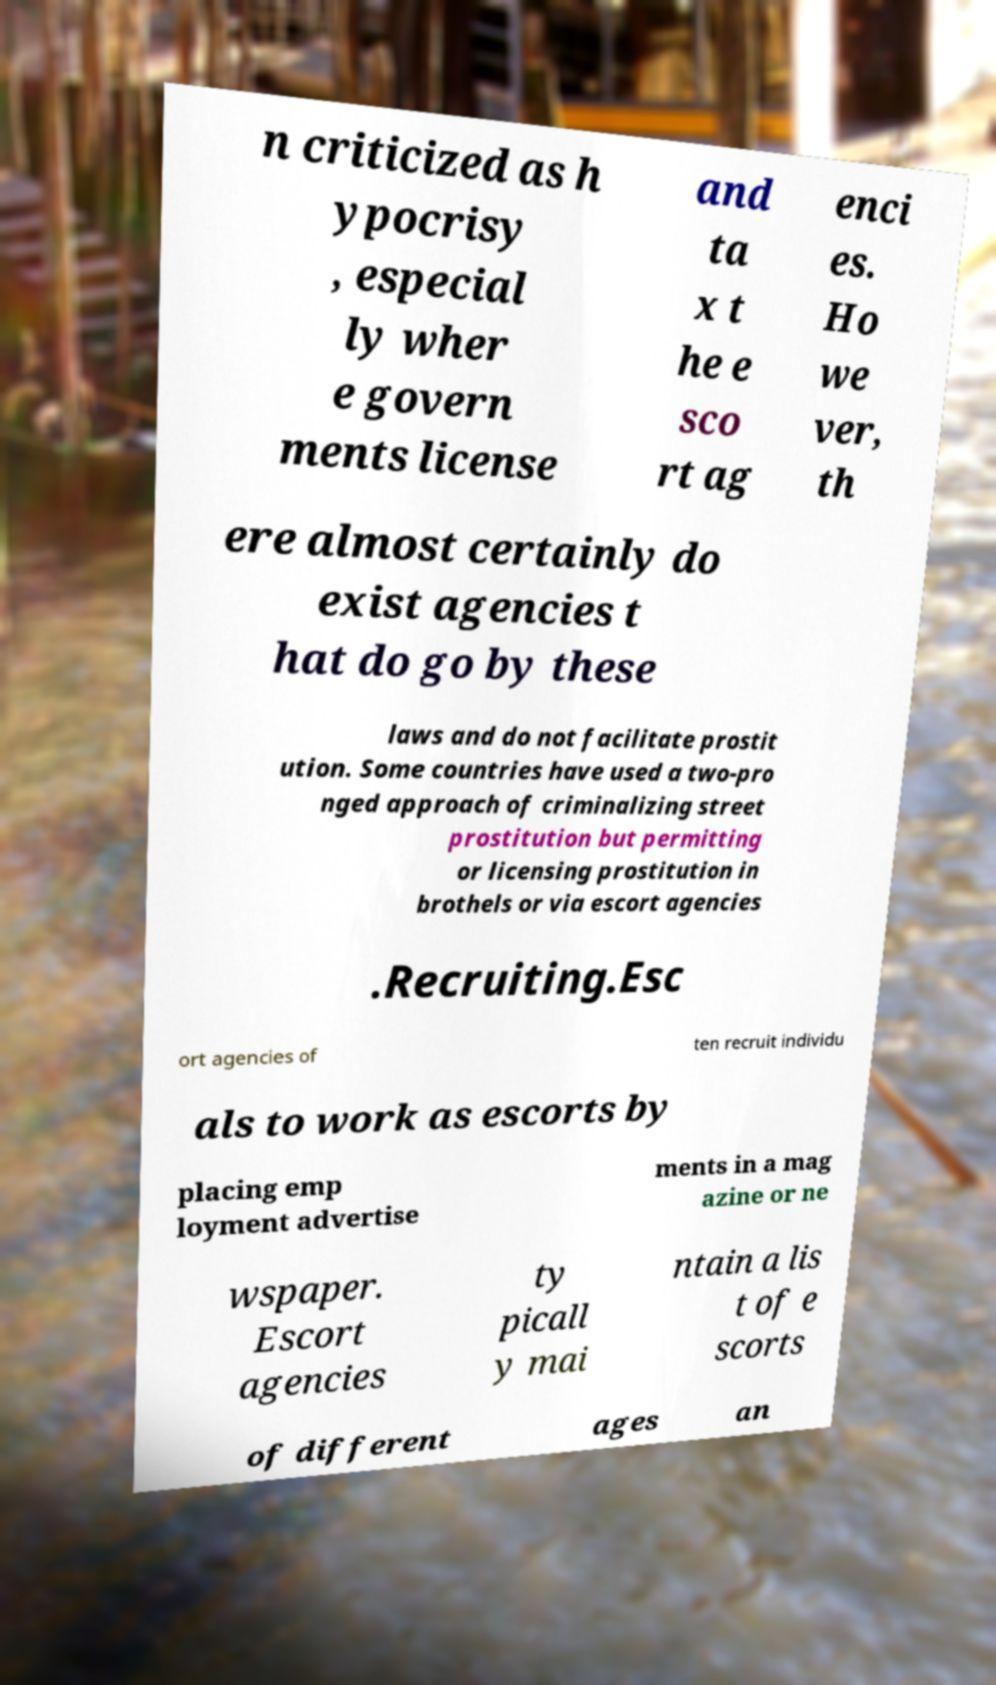For documentation purposes, I need the text within this image transcribed. Could you provide that? n criticized as h ypocrisy , especial ly wher e govern ments license and ta x t he e sco rt ag enci es. Ho we ver, th ere almost certainly do exist agencies t hat do go by these laws and do not facilitate prostit ution. Some countries have used a two-pro nged approach of criminalizing street prostitution but permitting or licensing prostitution in brothels or via escort agencies .Recruiting.Esc ort agencies of ten recruit individu als to work as escorts by placing emp loyment advertise ments in a mag azine or ne wspaper. Escort agencies ty picall y mai ntain a lis t of e scorts of different ages an 